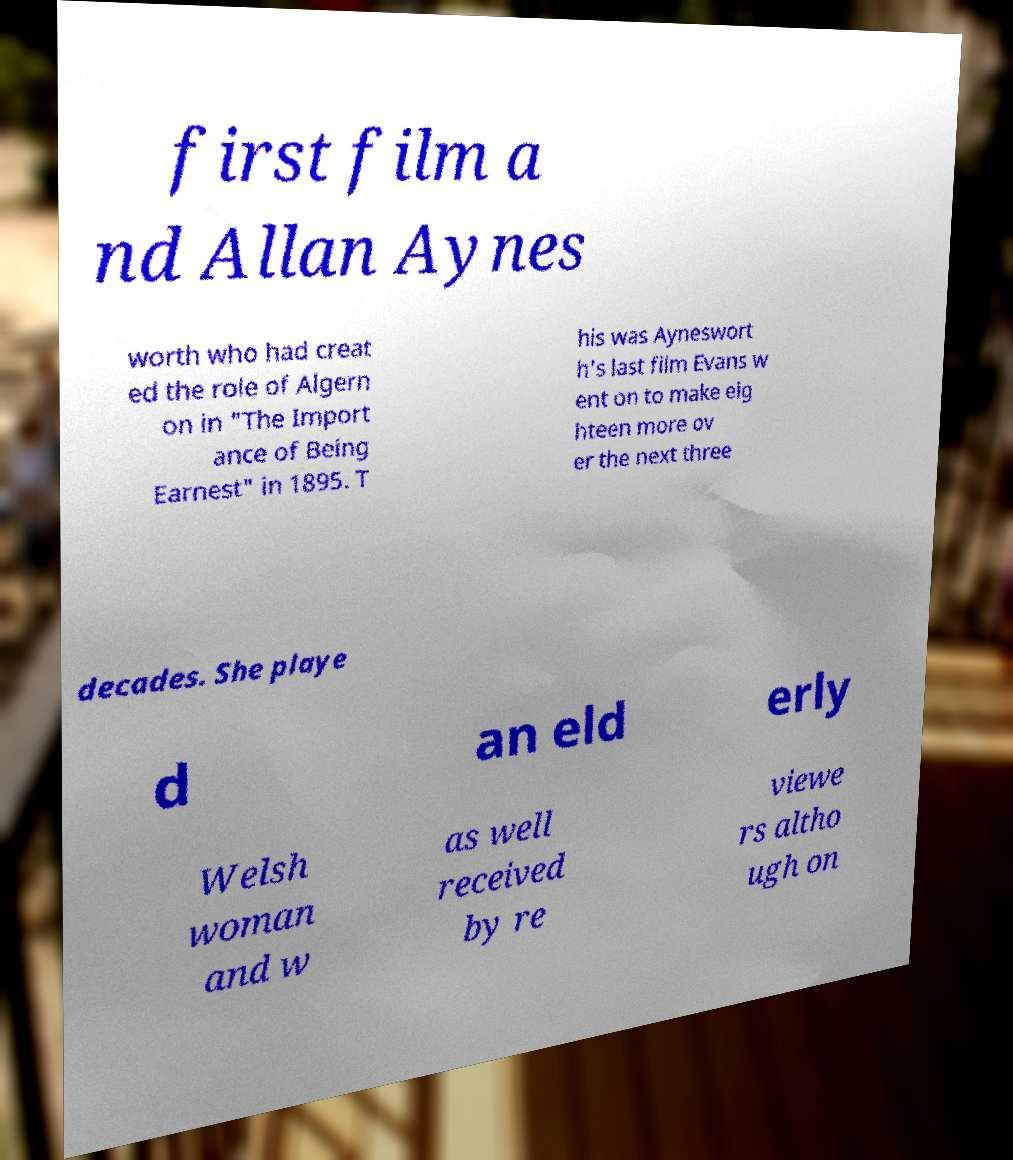For documentation purposes, I need the text within this image transcribed. Could you provide that? first film a nd Allan Aynes worth who had creat ed the role of Algern on in "The Import ance of Being Earnest" in 1895. T his was Ayneswort h's last film Evans w ent on to make eig hteen more ov er the next three decades. She playe d an eld erly Welsh woman and w as well received by re viewe rs altho ugh on 